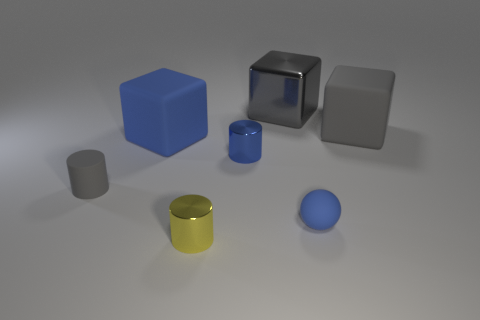What materials do the objects appear to be made of? The objects seem to be made of various materials. The blue and grey cubes have a matte finish suggesting a clay or plastic material, the metallic grey cube and the yellow cylinder look like metal due to their reflective surface, and the small sphere seems to have a rubbery texture. 